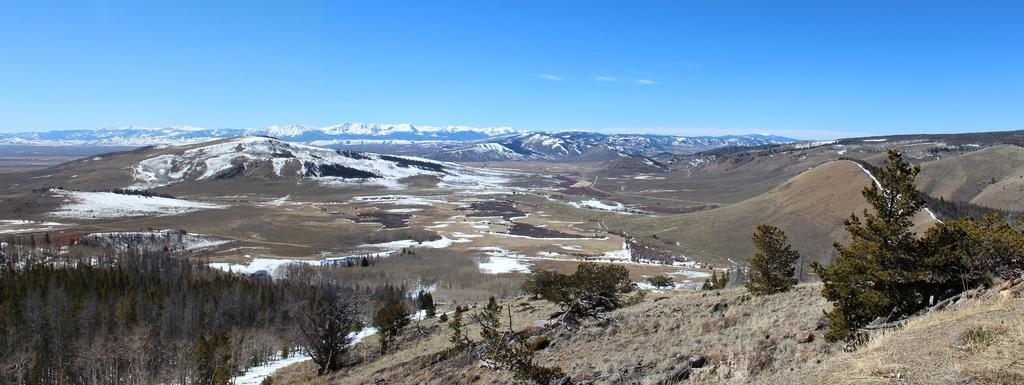What type of natural features can be seen in the image? There are trees, hills, and mountains visible in the image. What is the color of the sky in the background of the image? The sky is blue in the background of the image. Can you describe the terrain in the image? The terrain in the image includes trees, hills, and mountains. How many cows are grazing on the bean field in the image? There are no cows or bean fields present in the image. 